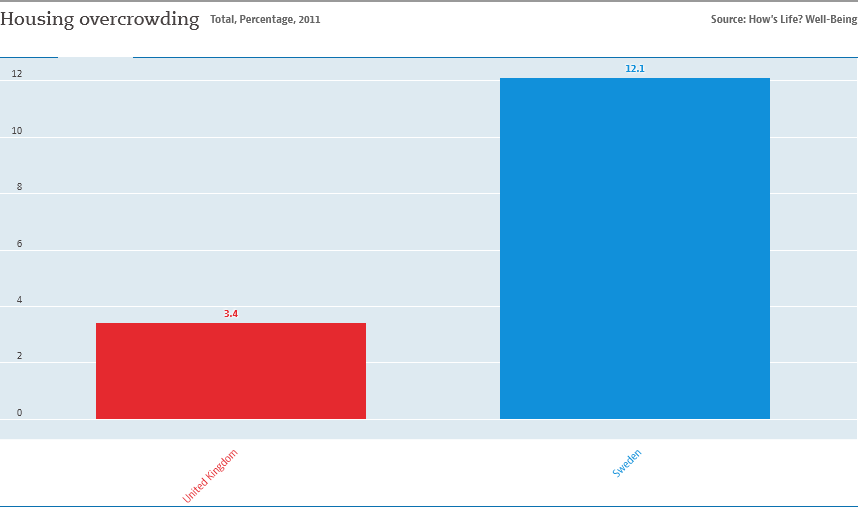Indicate a few pertinent items in this graphic. The total value of both bars is 15.5. The country represented by the RED bar is the United Kingdom. 